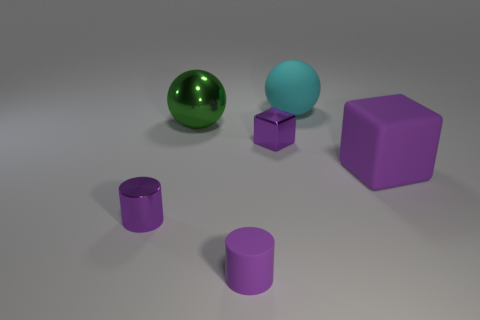Add 2 large balls. How many objects exist? 8 Subtract all spheres. How many objects are left? 4 Add 6 red metal blocks. How many red metal blocks exist? 6 Subtract 0 yellow spheres. How many objects are left? 6 Subtract all small shiny cylinders. Subtract all small matte cylinders. How many objects are left? 4 Add 5 cyan objects. How many cyan objects are left? 6 